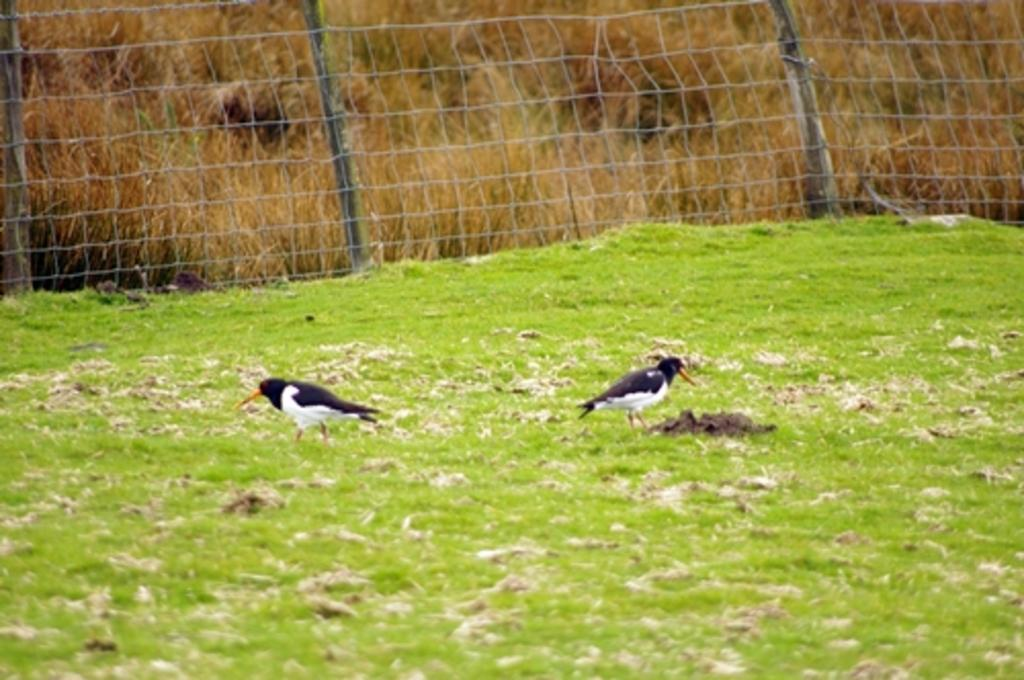What is the primary surface visible in the image? There is a ground in the image. What animals can be seen on the ground? There are two birds standing on the ground. What type of vegetation is present on the ground? There is grass on the ground. What additional feature can be seen in the image? There is a net visible in the image. What can be observed in the background of the image? Dried plants are present in the background of the image. Is there a garden party happening in the image? There is no indication of a garden party or any celebration in the image. 